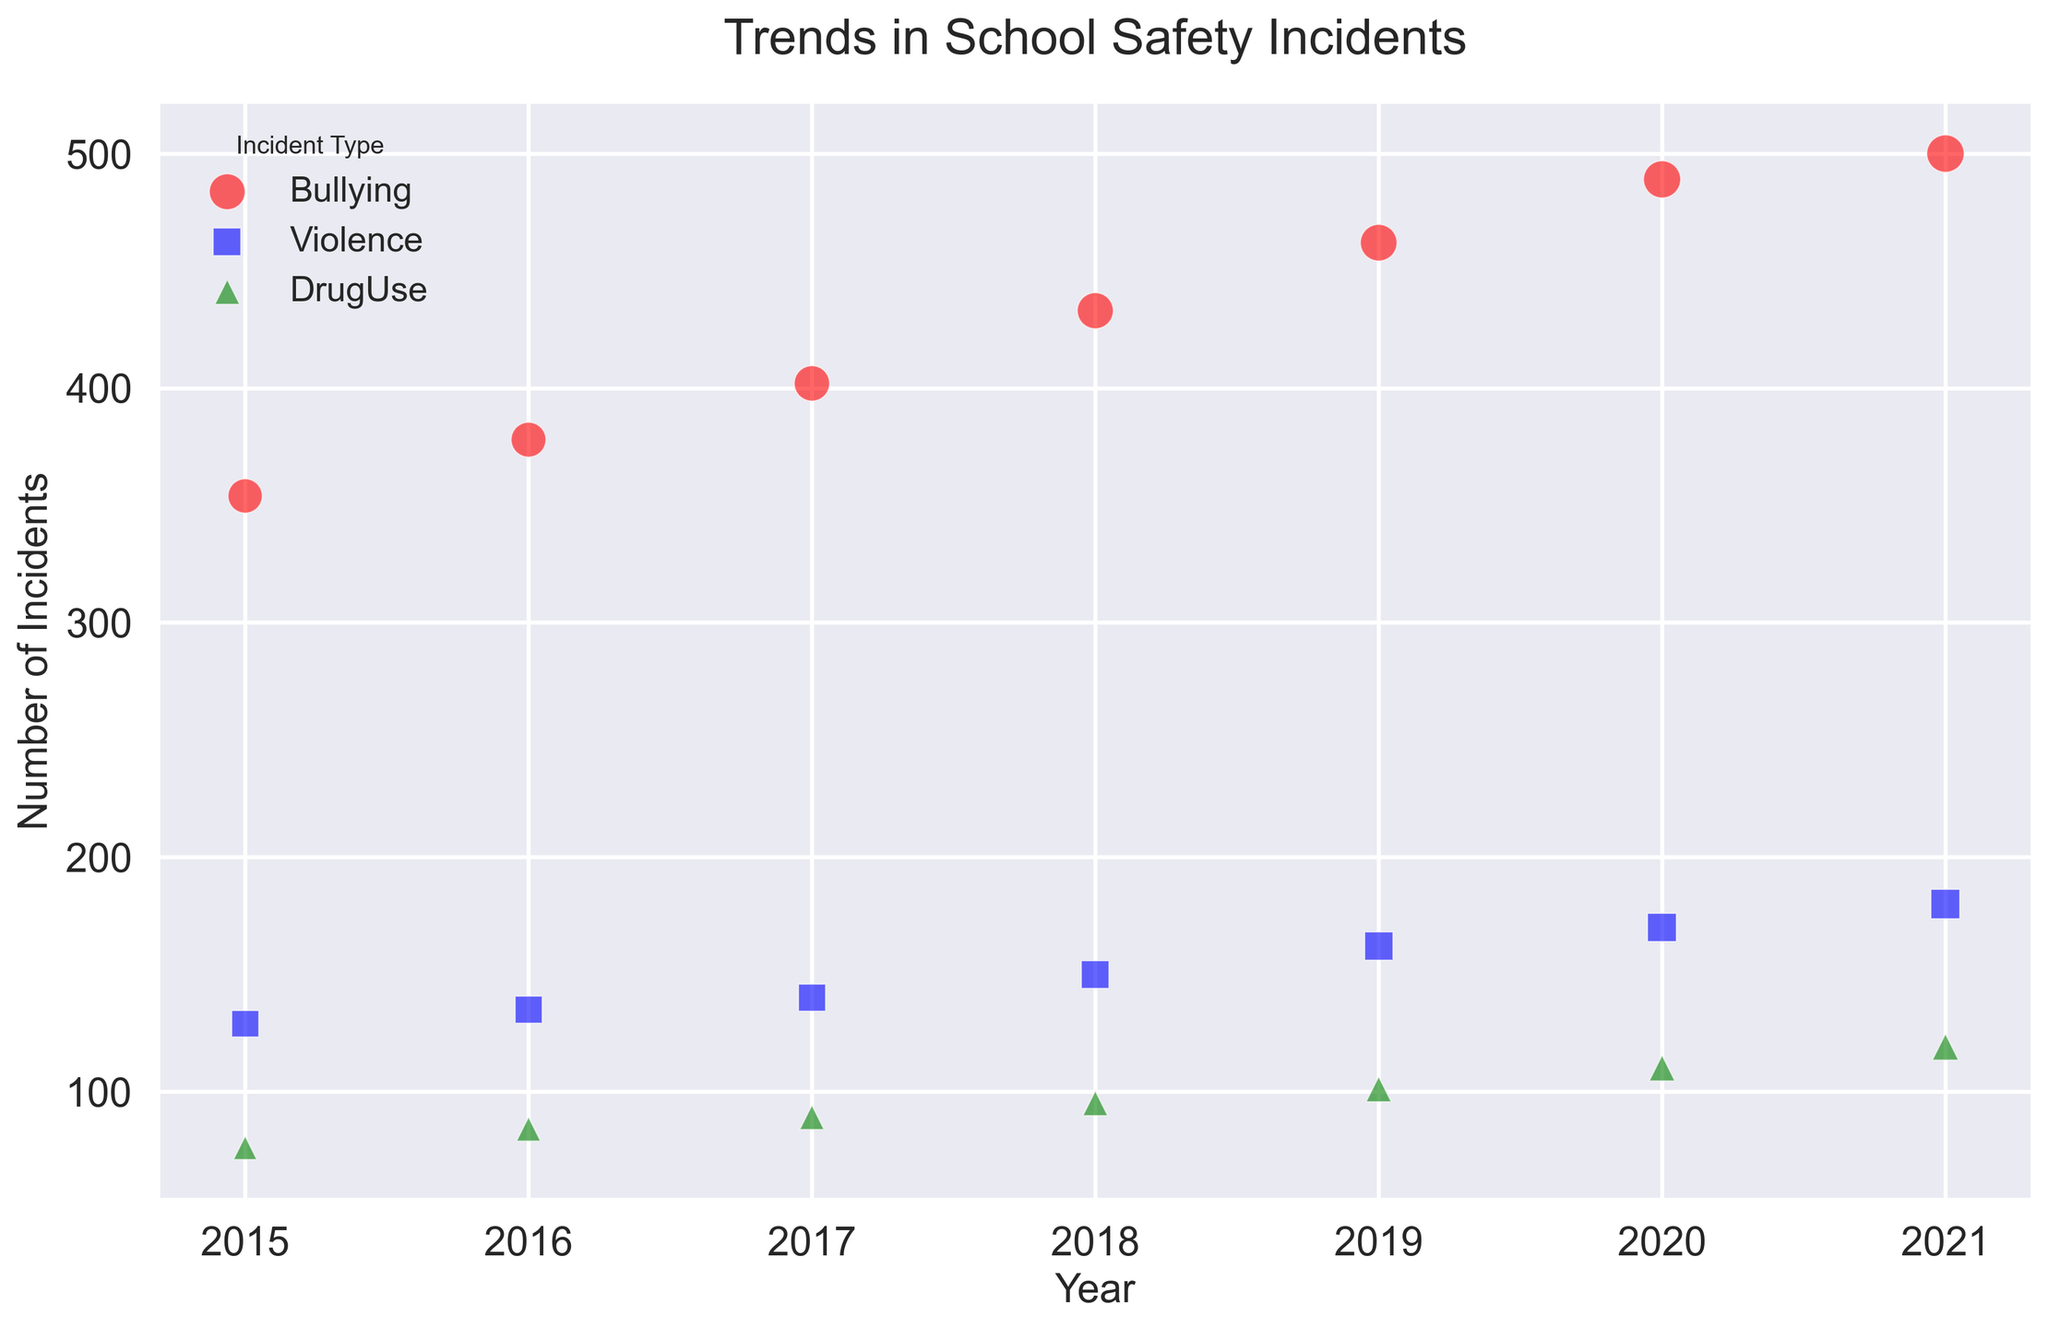What type of incident had the highest number of incidents in 2015? By looking at the positions of the markers along the vertical (y) axis for 2015, we can see that the red circle (representing Bullying) is placed higher than the other markers.
Answer: Bullying How did the number of bullying incidents change between 2015 and 2021? Bullying incidents are represented by red circles. The number of incidents increased clearly year over year, starting from 354 in 2015 and reaching 500 in 2021.
Answer: Increased Which incident type showed the fastest rate of increase from 2015 to 2021? To determine the fastest rate of increase, we need to compare the slopes of the lines formed by the markers of each incident type. Bullying shows the steepest incline, indicating the fastest rate of increase.
Answer: Bullying Compare the number of violent incidents in 2017 and 2019. Violence is marked by blue squares. For 2017, the number of violent incidents is 140, and for 2019, it is 162. Comparing these values, we can see an increase.
Answer: Increased Which incident type has the smallest change in the number of incidents from 2015 to 2021? We can compare the vertical (y) positions of the markers from 2015 to 2021 for each incident type. Drug use (green triangle) shows the smallest vertical distance between 2015 (76) and 2021 (119).
Answer: DrugUse How many more bullying incidents were there in 2021 compared to drug use incidents in the same year? For 2021, bullying incidents are 500, and drug use incidents are 119. The difference is 500 - 119 = 381.
Answer: 381 What is the average number of incidents for violent cases from 2015 to 2021? The numbers for violence are: (129, 135, 140, 150, 162, 170, 180). Sum them: 129 + 135 + 140 + 150 + 162 + 170 + 180 = 1066. The average is 1066 / 7 = 152.29.
Answer: 152.29 In which year did drug use incidents first exceed 100? We look at the years when the green triangles surpass the 100 mark on the y-axis. This occurred in 2019.
Answer: 2019 What incident type shows a consistent yearly increase with no year showing a decrease? By examining the markers, Bullying (red circles) shows a consistent yearly increase from 2015 to 2021 with no decrease in numbers.
Answer: Bullying Is there any year where the number of violent incidents is equal to the number of drug use incidents? Reviewing the blue squares and green triangles, there is no year where the heights of these two markers are exactly the same.
Answer: No 